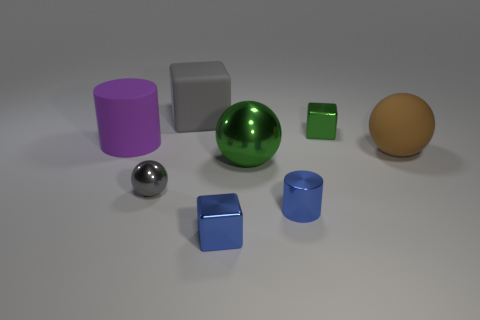How does the lighting in this image affect the appearance of the objects? The lighting in this image is soft and diffused, casting gentle shadows and highlighting the objects' textures and colors. This type of lighting reduces harsh contrasts and allows the materials, whether metallic, matte, or translucent, to retain depth and detail. 